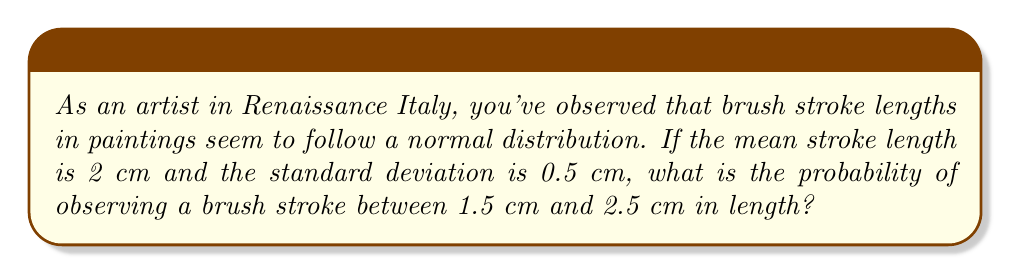Can you answer this question? To solve this problem, we'll use the properties of the normal distribution and the concept of z-scores.

Step 1: Identify the given information
- Mean (μ) = 2 cm
- Standard deviation (σ) = 0.5 cm
- We want to find P(1.5 ≤ X ≤ 2.5)

Step 2: Calculate the z-scores for the lower and upper bounds
For x = 1.5 cm:
$z_1 = \frac{x - \mu}{\sigma} = \frac{1.5 - 2}{0.5} = -1$

For x = 2.5 cm:
$z_2 = \frac{x - \mu}{\sigma} = \frac{2.5 - 2}{0.5} = 1$

Step 3: Use the standard normal distribution table or calculator to find the area
The probability is the area between z = -1 and z = 1 under the standard normal curve.

$P(-1 \leq Z \leq 1) = P(Z \leq 1) - P(Z \leq -1)$

Using a standard normal table or calculator:
$P(Z \leq 1) \approx 0.8413$
$P(Z \leq -1) \approx 0.1587$

Step 4: Calculate the final probability
$P(1.5 \leq X \leq 2.5) = P(-1 \leq Z \leq 1) = 0.8413 - 0.1587 = 0.6826$

Therefore, the probability of observing a brush stroke between 1.5 cm and 2.5 cm in length is approximately 0.6826 or 68.26%.
Answer: 0.6826 